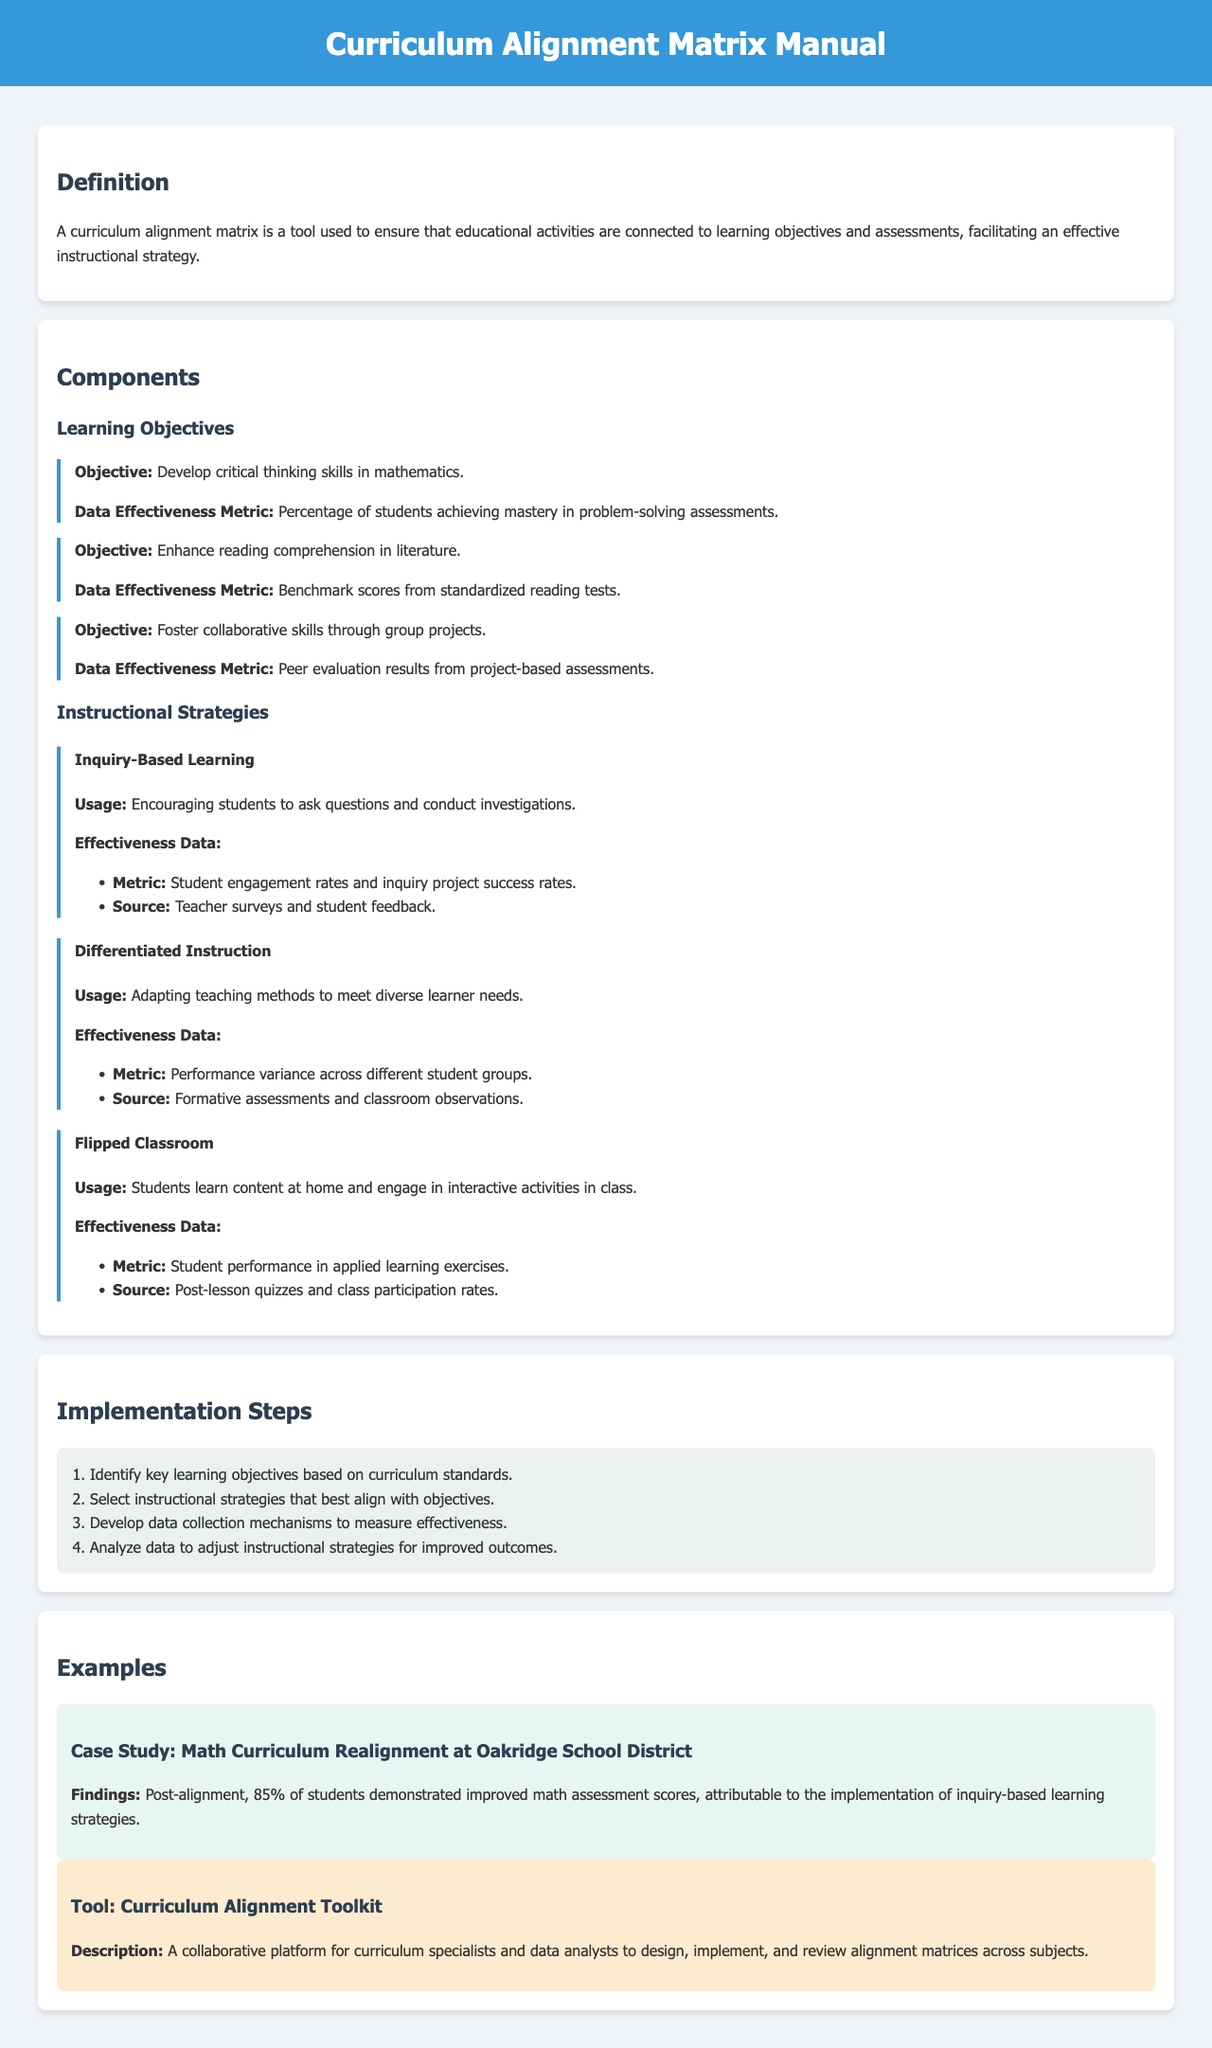What is the purpose of a curriculum alignment matrix? The purpose of a curriculum alignment matrix is to ensure that educational activities are connected to learning objectives and assessments, facilitating an effective instructional strategy.
Answer: Ensure educational activities are connected to learning objectives What methodology does the flipped classroom strategy use? The flipped classroom strategy uses a methodology where students learn content at home and engage in interactive activities in class.
Answer: Students learn content at home What is the data effectiveness metric for enhancing reading comprehension in literature? The data effectiveness metric for enhancing reading comprehension in literature is the benchmark scores from standardized reading tests.
Answer: Benchmark scores from standardized reading tests What percentage of students demonstrated improved math assessment scores post-alignment in the case study? Post-alignment, 85% of students demonstrated improved math assessment scores in the case study.
Answer: 85% What is the first step in the implementation process? The first step in the implementation process is to identify key learning objectives based on curriculum standards.
Answer: Identify key learning objectives What type of learning does inquiry-based learning encourage? Inquiry-based learning encourages students to ask questions and conduct investigations.
Answer: Ask questions and conduct investigations What is the description of the Curriculum Alignment Toolkit? The description of the Curriculum Alignment Toolkit is that it is a collaborative platform for curriculum specialists and data analysts to design, implement, and review alignment matrices across subjects.
Answer: A collaborative platform for curriculum specialists and data analysts What is the effectiveness metric for differentiated instruction? The effectiveness metric for differentiated instruction is the performance variance across different student groups.
Answer: Performance variance across different student groups What should be selected after identifying key learning objectives? The next step after identifying key learning objectives is to select instructional strategies that best align with objectives.
Answer: Select instructional strategies 